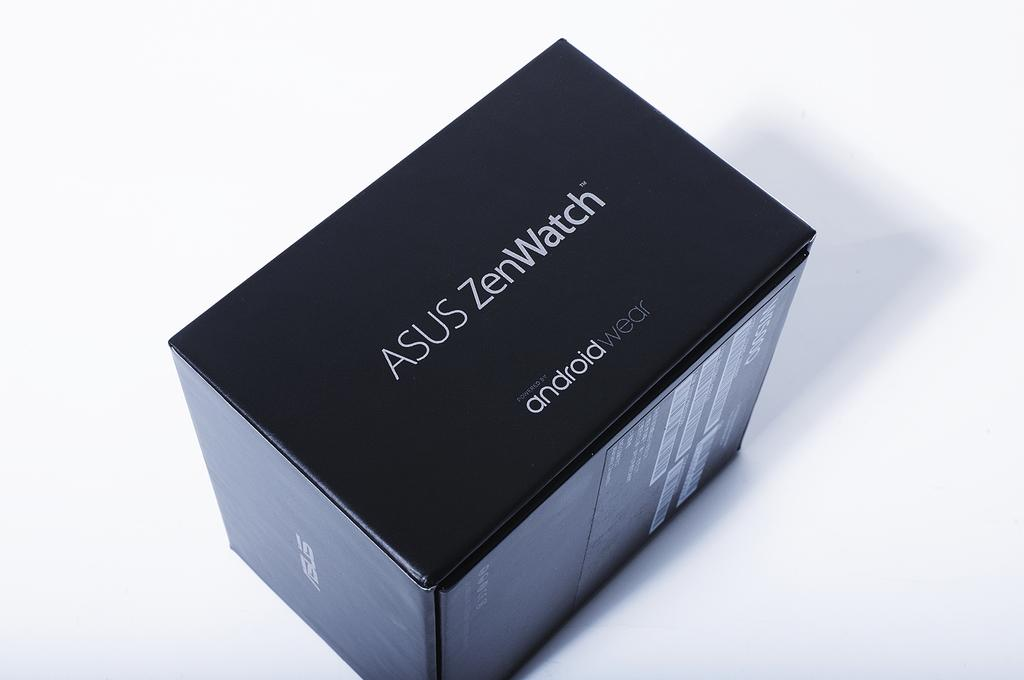<image>
Relay a brief, clear account of the picture shown. Smartwatch from Asus that is an android type product. 